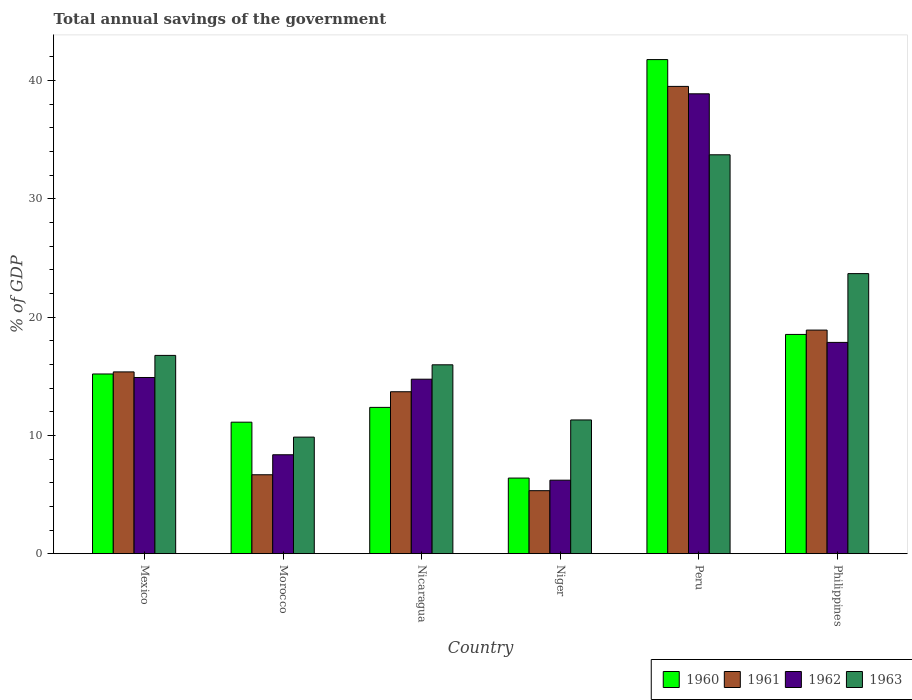How many different coloured bars are there?
Ensure brevity in your answer.  4. Are the number of bars per tick equal to the number of legend labels?
Your response must be concise. Yes. Are the number of bars on each tick of the X-axis equal?
Provide a short and direct response. Yes. How many bars are there on the 2nd tick from the right?
Make the answer very short. 4. What is the label of the 5th group of bars from the left?
Your answer should be compact. Peru. What is the total annual savings of the government in 1961 in Peru?
Keep it short and to the point. 39.51. Across all countries, what is the maximum total annual savings of the government in 1961?
Your answer should be compact. 39.51. Across all countries, what is the minimum total annual savings of the government in 1960?
Offer a terse response. 6.39. In which country was the total annual savings of the government in 1960 minimum?
Ensure brevity in your answer.  Niger. What is the total total annual savings of the government in 1963 in the graph?
Keep it short and to the point. 111.29. What is the difference between the total annual savings of the government in 1960 in Mexico and that in Nicaragua?
Keep it short and to the point. 2.82. What is the difference between the total annual savings of the government in 1961 in Niger and the total annual savings of the government in 1962 in Peru?
Your answer should be compact. -33.56. What is the average total annual savings of the government in 1960 per country?
Give a very brief answer. 17.56. What is the difference between the total annual savings of the government of/in 1962 and total annual savings of the government of/in 1961 in Mexico?
Keep it short and to the point. -0.47. What is the ratio of the total annual savings of the government in 1963 in Morocco to that in Nicaragua?
Give a very brief answer. 0.62. What is the difference between the highest and the second highest total annual savings of the government in 1960?
Your answer should be compact. 23.24. What is the difference between the highest and the lowest total annual savings of the government in 1960?
Give a very brief answer. 35.38. Is the sum of the total annual savings of the government in 1962 in Morocco and Nicaragua greater than the maximum total annual savings of the government in 1963 across all countries?
Offer a terse response. No. Is it the case that in every country, the sum of the total annual savings of the government in 1963 and total annual savings of the government in 1962 is greater than the sum of total annual savings of the government in 1960 and total annual savings of the government in 1961?
Give a very brief answer. No. Is it the case that in every country, the sum of the total annual savings of the government in 1961 and total annual savings of the government in 1963 is greater than the total annual savings of the government in 1962?
Your answer should be compact. Yes. Are all the bars in the graph horizontal?
Offer a terse response. No. What is the difference between two consecutive major ticks on the Y-axis?
Your response must be concise. 10. Are the values on the major ticks of Y-axis written in scientific E-notation?
Give a very brief answer. No. Does the graph contain grids?
Offer a terse response. No. What is the title of the graph?
Your response must be concise. Total annual savings of the government. Does "2002" appear as one of the legend labels in the graph?
Your answer should be compact. No. What is the label or title of the X-axis?
Ensure brevity in your answer.  Country. What is the label or title of the Y-axis?
Your answer should be very brief. % of GDP. What is the % of GDP in 1960 in Mexico?
Your response must be concise. 15.19. What is the % of GDP of 1961 in Mexico?
Provide a succinct answer. 15.37. What is the % of GDP in 1962 in Mexico?
Ensure brevity in your answer.  14.89. What is the % of GDP of 1963 in Mexico?
Provide a succinct answer. 16.76. What is the % of GDP in 1960 in Morocco?
Provide a succinct answer. 11.12. What is the % of GDP of 1961 in Morocco?
Make the answer very short. 6.67. What is the % of GDP in 1962 in Morocco?
Provide a short and direct response. 8.36. What is the % of GDP of 1963 in Morocco?
Offer a very short reply. 9.85. What is the % of GDP of 1960 in Nicaragua?
Keep it short and to the point. 12.37. What is the % of GDP in 1961 in Nicaragua?
Give a very brief answer. 13.69. What is the % of GDP of 1962 in Nicaragua?
Your answer should be compact. 14.75. What is the % of GDP of 1963 in Nicaragua?
Provide a succinct answer. 15.97. What is the % of GDP in 1960 in Niger?
Your answer should be very brief. 6.39. What is the % of GDP of 1961 in Niger?
Your response must be concise. 5.32. What is the % of GDP of 1962 in Niger?
Make the answer very short. 6.21. What is the % of GDP in 1963 in Niger?
Keep it short and to the point. 11.31. What is the % of GDP of 1960 in Peru?
Your answer should be compact. 41.78. What is the % of GDP in 1961 in Peru?
Ensure brevity in your answer.  39.51. What is the % of GDP of 1962 in Peru?
Give a very brief answer. 38.88. What is the % of GDP in 1963 in Peru?
Provide a succinct answer. 33.73. What is the % of GDP in 1960 in Philippines?
Give a very brief answer. 18.54. What is the % of GDP in 1961 in Philippines?
Offer a terse response. 18.9. What is the % of GDP in 1962 in Philippines?
Make the answer very short. 17.86. What is the % of GDP in 1963 in Philippines?
Provide a short and direct response. 23.68. Across all countries, what is the maximum % of GDP in 1960?
Offer a terse response. 41.78. Across all countries, what is the maximum % of GDP of 1961?
Keep it short and to the point. 39.51. Across all countries, what is the maximum % of GDP in 1962?
Ensure brevity in your answer.  38.88. Across all countries, what is the maximum % of GDP in 1963?
Ensure brevity in your answer.  33.73. Across all countries, what is the minimum % of GDP in 1960?
Ensure brevity in your answer.  6.39. Across all countries, what is the minimum % of GDP of 1961?
Offer a terse response. 5.32. Across all countries, what is the minimum % of GDP of 1962?
Offer a terse response. 6.21. Across all countries, what is the minimum % of GDP in 1963?
Your answer should be very brief. 9.85. What is the total % of GDP of 1960 in the graph?
Your answer should be compact. 105.38. What is the total % of GDP in 1961 in the graph?
Ensure brevity in your answer.  99.46. What is the total % of GDP of 1962 in the graph?
Your answer should be compact. 100.96. What is the total % of GDP in 1963 in the graph?
Your answer should be very brief. 111.3. What is the difference between the % of GDP of 1960 in Mexico and that in Morocco?
Your response must be concise. 4.08. What is the difference between the % of GDP of 1961 in Mexico and that in Morocco?
Provide a succinct answer. 8.7. What is the difference between the % of GDP of 1962 in Mexico and that in Morocco?
Your answer should be very brief. 6.53. What is the difference between the % of GDP in 1963 in Mexico and that in Morocco?
Provide a succinct answer. 6.91. What is the difference between the % of GDP of 1960 in Mexico and that in Nicaragua?
Provide a succinct answer. 2.82. What is the difference between the % of GDP in 1961 in Mexico and that in Nicaragua?
Keep it short and to the point. 1.68. What is the difference between the % of GDP of 1962 in Mexico and that in Nicaragua?
Offer a very short reply. 0.14. What is the difference between the % of GDP in 1963 in Mexico and that in Nicaragua?
Offer a terse response. 0.8. What is the difference between the % of GDP in 1960 in Mexico and that in Niger?
Provide a short and direct response. 8.8. What is the difference between the % of GDP in 1961 in Mexico and that in Niger?
Your answer should be very brief. 10.04. What is the difference between the % of GDP in 1962 in Mexico and that in Niger?
Provide a succinct answer. 8.68. What is the difference between the % of GDP of 1963 in Mexico and that in Niger?
Ensure brevity in your answer.  5.46. What is the difference between the % of GDP of 1960 in Mexico and that in Peru?
Your answer should be very brief. -26.58. What is the difference between the % of GDP in 1961 in Mexico and that in Peru?
Give a very brief answer. -24.14. What is the difference between the % of GDP in 1962 in Mexico and that in Peru?
Give a very brief answer. -23.99. What is the difference between the % of GDP in 1963 in Mexico and that in Peru?
Give a very brief answer. -16.96. What is the difference between the % of GDP in 1960 in Mexico and that in Philippines?
Offer a terse response. -3.34. What is the difference between the % of GDP in 1961 in Mexico and that in Philippines?
Ensure brevity in your answer.  -3.54. What is the difference between the % of GDP of 1962 in Mexico and that in Philippines?
Provide a short and direct response. -2.97. What is the difference between the % of GDP in 1963 in Mexico and that in Philippines?
Your response must be concise. -6.92. What is the difference between the % of GDP of 1960 in Morocco and that in Nicaragua?
Ensure brevity in your answer.  -1.25. What is the difference between the % of GDP in 1961 in Morocco and that in Nicaragua?
Keep it short and to the point. -7.02. What is the difference between the % of GDP of 1962 in Morocco and that in Nicaragua?
Provide a short and direct response. -6.39. What is the difference between the % of GDP of 1963 in Morocco and that in Nicaragua?
Offer a very short reply. -6.11. What is the difference between the % of GDP of 1960 in Morocco and that in Niger?
Your answer should be compact. 4.73. What is the difference between the % of GDP of 1961 in Morocco and that in Niger?
Your answer should be very brief. 1.35. What is the difference between the % of GDP of 1962 in Morocco and that in Niger?
Provide a succinct answer. 2.15. What is the difference between the % of GDP in 1963 in Morocco and that in Niger?
Your answer should be very brief. -1.45. What is the difference between the % of GDP of 1960 in Morocco and that in Peru?
Make the answer very short. -30.66. What is the difference between the % of GDP in 1961 in Morocco and that in Peru?
Offer a terse response. -32.84. What is the difference between the % of GDP of 1962 in Morocco and that in Peru?
Keep it short and to the point. -30.52. What is the difference between the % of GDP of 1963 in Morocco and that in Peru?
Offer a very short reply. -23.87. What is the difference between the % of GDP in 1960 in Morocco and that in Philippines?
Your response must be concise. -7.42. What is the difference between the % of GDP in 1961 in Morocco and that in Philippines?
Make the answer very short. -12.23. What is the difference between the % of GDP of 1963 in Morocco and that in Philippines?
Your response must be concise. -13.82. What is the difference between the % of GDP in 1960 in Nicaragua and that in Niger?
Provide a short and direct response. 5.98. What is the difference between the % of GDP of 1961 in Nicaragua and that in Niger?
Your answer should be compact. 8.37. What is the difference between the % of GDP in 1962 in Nicaragua and that in Niger?
Give a very brief answer. 8.54. What is the difference between the % of GDP in 1963 in Nicaragua and that in Niger?
Ensure brevity in your answer.  4.66. What is the difference between the % of GDP of 1960 in Nicaragua and that in Peru?
Your response must be concise. -29.41. What is the difference between the % of GDP in 1961 in Nicaragua and that in Peru?
Keep it short and to the point. -25.82. What is the difference between the % of GDP of 1962 in Nicaragua and that in Peru?
Offer a terse response. -24.13. What is the difference between the % of GDP in 1963 in Nicaragua and that in Peru?
Your response must be concise. -17.76. What is the difference between the % of GDP of 1960 in Nicaragua and that in Philippines?
Offer a very short reply. -6.17. What is the difference between the % of GDP of 1961 in Nicaragua and that in Philippines?
Provide a succinct answer. -5.21. What is the difference between the % of GDP in 1962 in Nicaragua and that in Philippines?
Ensure brevity in your answer.  -3.11. What is the difference between the % of GDP in 1963 in Nicaragua and that in Philippines?
Keep it short and to the point. -7.71. What is the difference between the % of GDP in 1960 in Niger and that in Peru?
Make the answer very short. -35.38. What is the difference between the % of GDP of 1961 in Niger and that in Peru?
Your response must be concise. -34.18. What is the difference between the % of GDP of 1962 in Niger and that in Peru?
Make the answer very short. -32.67. What is the difference between the % of GDP of 1963 in Niger and that in Peru?
Keep it short and to the point. -22.42. What is the difference between the % of GDP of 1960 in Niger and that in Philippines?
Offer a very short reply. -12.15. What is the difference between the % of GDP in 1961 in Niger and that in Philippines?
Your answer should be very brief. -13.58. What is the difference between the % of GDP in 1962 in Niger and that in Philippines?
Give a very brief answer. -11.65. What is the difference between the % of GDP of 1963 in Niger and that in Philippines?
Your answer should be very brief. -12.37. What is the difference between the % of GDP of 1960 in Peru and that in Philippines?
Provide a short and direct response. 23.24. What is the difference between the % of GDP of 1961 in Peru and that in Philippines?
Offer a terse response. 20.6. What is the difference between the % of GDP of 1962 in Peru and that in Philippines?
Your answer should be compact. 21.02. What is the difference between the % of GDP of 1963 in Peru and that in Philippines?
Your answer should be very brief. 10.05. What is the difference between the % of GDP in 1960 in Mexico and the % of GDP in 1961 in Morocco?
Make the answer very short. 8.52. What is the difference between the % of GDP of 1960 in Mexico and the % of GDP of 1962 in Morocco?
Your answer should be very brief. 6.83. What is the difference between the % of GDP in 1960 in Mexico and the % of GDP in 1963 in Morocco?
Provide a succinct answer. 5.34. What is the difference between the % of GDP in 1961 in Mexico and the % of GDP in 1962 in Morocco?
Your response must be concise. 7.01. What is the difference between the % of GDP of 1961 in Mexico and the % of GDP of 1963 in Morocco?
Your response must be concise. 5.51. What is the difference between the % of GDP in 1962 in Mexico and the % of GDP in 1963 in Morocco?
Provide a short and direct response. 5.04. What is the difference between the % of GDP of 1960 in Mexico and the % of GDP of 1961 in Nicaragua?
Your response must be concise. 1.5. What is the difference between the % of GDP of 1960 in Mexico and the % of GDP of 1962 in Nicaragua?
Provide a succinct answer. 0.44. What is the difference between the % of GDP of 1960 in Mexico and the % of GDP of 1963 in Nicaragua?
Make the answer very short. -0.78. What is the difference between the % of GDP of 1961 in Mexico and the % of GDP of 1962 in Nicaragua?
Make the answer very short. 0.62. What is the difference between the % of GDP in 1961 in Mexico and the % of GDP in 1963 in Nicaragua?
Your answer should be very brief. -0.6. What is the difference between the % of GDP in 1962 in Mexico and the % of GDP in 1963 in Nicaragua?
Provide a succinct answer. -1.07. What is the difference between the % of GDP of 1960 in Mexico and the % of GDP of 1961 in Niger?
Your answer should be very brief. 9.87. What is the difference between the % of GDP of 1960 in Mexico and the % of GDP of 1962 in Niger?
Your answer should be very brief. 8.98. What is the difference between the % of GDP in 1960 in Mexico and the % of GDP in 1963 in Niger?
Offer a terse response. 3.89. What is the difference between the % of GDP of 1961 in Mexico and the % of GDP of 1962 in Niger?
Provide a short and direct response. 9.16. What is the difference between the % of GDP of 1961 in Mexico and the % of GDP of 1963 in Niger?
Ensure brevity in your answer.  4.06. What is the difference between the % of GDP of 1962 in Mexico and the % of GDP of 1963 in Niger?
Your response must be concise. 3.59. What is the difference between the % of GDP of 1960 in Mexico and the % of GDP of 1961 in Peru?
Provide a succinct answer. -24.32. What is the difference between the % of GDP in 1960 in Mexico and the % of GDP in 1962 in Peru?
Offer a terse response. -23.69. What is the difference between the % of GDP of 1960 in Mexico and the % of GDP of 1963 in Peru?
Give a very brief answer. -18.53. What is the difference between the % of GDP in 1961 in Mexico and the % of GDP in 1962 in Peru?
Your answer should be very brief. -23.51. What is the difference between the % of GDP in 1961 in Mexico and the % of GDP in 1963 in Peru?
Offer a terse response. -18.36. What is the difference between the % of GDP of 1962 in Mexico and the % of GDP of 1963 in Peru?
Offer a terse response. -18.83. What is the difference between the % of GDP in 1960 in Mexico and the % of GDP in 1961 in Philippines?
Make the answer very short. -3.71. What is the difference between the % of GDP in 1960 in Mexico and the % of GDP in 1962 in Philippines?
Keep it short and to the point. -2.67. What is the difference between the % of GDP of 1960 in Mexico and the % of GDP of 1963 in Philippines?
Provide a short and direct response. -8.49. What is the difference between the % of GDP of 1961 in Mexico and the % of GDP of 1962 in Philippines?
Offer a very short reply. -2.49. What is the difference between the % of GDP in 1961 in Mexico and the % of GDP in 1963 in Philippines?
Your answer should be very brief. -8.31. What is the difference between the % of GDP of 1962 in Mexico and the % of GDP of 1963 in Philippines?
Keep it short and to the point. -8.78. What is the difference between the % of GDP in 1960 in Morocco and the % of GDP in 1961 in Nicaragua?
Your response must be concise. -2.57. What is the difference between the % of GDP of 1960 in Morocco and the % of GDP of 1962 in Nicaragua?
Offer a very short reply. -3.63. What is the difference between the % of GDP in 1960 in Morocco and the % of GDP in 1963 in Nicaragua?
Offer a very short reply. -4.85. What is the difference between the % of GDP of 1961 in Morocco and the % of GDP of 1962 in Nicaragua?
Your answer should be very brief. -8.08. What is the difference between the % of GDP of 1961 in Morocco and the % of GDP of 1963 in Nicaragua?
Offer a terse response. -9.3. What is the difference between the % of GDP of 1962 in Morocco and the % of GDP of 1963 in Nicaragua?
Provide a succinct answer. -7.61. What is the difference between the % of GDP of 1960 in Morocco and the % of GDP of 1961 in Niger?
Offer a terse response. 5.79. What is the difference between the % of GDP in 1960 in Morocco and the % of GDP in 1962 in Niger?
Provide a succinct answer. 4.9. What is the difference between the % of GDP in 1960 in Morocco and the % of GDP in 1963 in Niger?
Keep it short and to the point. -0.19. What is the difference between the % of GDP of 1961 in Morocco and the % of GDP of 1962 in Niger?
Give a very brief answer. 0.46. What is the difference between the % of GDP of 1961 in Morocco and the % of GDP of 1963 in Niger?
Your response must be concise. -4.63. What is the difference between the % of GDP of 1962 in Morocco and the % of GDP of 1963 in Niger?
Offer a terse response. -2.94. What is the difference between the % of GDP of 1960 in Morocco and the % of GDP of 1961 in Peru?
Your answer should be compact. -28.39. What is the difference between the % of GDP of 1960 in Morocco and the % of GDP of 1962 in Peru?
Provide a succinct answer. -27.76. What is the difference between the % of GDP of 1960 in Morocco and the % of GDP of 1963 in Peru?
Your answer should be very brief. -22.61. What is the difference between the % of GDP of 1961 in Morocco and the % of GDP of 1962 in Peru?
Your response must be concise. -32.21. What is the difference between the % of GDP of 1961 in Morocco and the % of GDP of 1963 in Peru?
Your response must be concise. -27.05. What is the difference between the % of GDP in 1962 in Morocco and the % of GDP in 1963 in Peru?
Keep it short and to the point. -25.36. What is the difference between the % of GDP in 1960 in Morocco and the % of GDP in 1961 in Philippines?
Provide a succinct answer. -7.79. What is the difference between the % of GDP of 1960 in Morocco and the % of GDP of 1962 in Philippines?
Provide a short and direct response. -6.75. What is the difference between the % of GDP in 1960 in Morocco and the % of GDP in 1963 in Philippines?
Your response must be concise. -12.56. What is the difference between the % of GDP of 1961 in Morocco and the % of GDP of 1962 in Philippines?
Make the answer very short. -11.19. What is the difference between the % of GDP in 1961 in Morocco and the % of GDP in 1963 in Philippines?
Give a very brief answer. -17.01. What is the difference between the % of GDP in 1962 in Morocco and the % of GDP in 1963 in Philippines?
Provide a short and direct response. -15.32. What is the difference between the % of GDP in 1960 in Nicaragua and the % of GDP in 1961 in Niger?
Your answer should be very brief. 7.04. What is the difference between the % of GDP of 1960 in Nicaragua and the % of GDP of 1962 in Niger?
Your response must be concise. 6.16. What is the difference between the % of GDP in 1960 in Nicaragua and the % of GDP in 1963 in Niger?
Your answer should be very brief. 1.06. What is the difference between the % of GDP of 1961 in Nicaragua and the % of GDP of 1962 in Niger?
Offer a very short reply. 7.48. What is the difference between the % of GDP in 1961 in Nicaragua and the % of GDP in 1963 in Niger?
Your answer should be compact. 2.38. What is the difference between the % of GDP of 1962 in Nicaragua and the % of GDP of 1963 in Niger?
Provide a short and direct response. 3.45. What is the difference between the % of GDP of 1960 in Nicaragua and the % of GDP of 1961 in Peru?
Keep it short and to the point. -27.14. What is the difference between the % of GDP of 1960 in Nicaragua and the % of GDP of 1962 in Peru?
Give a very brief answer. -26.51. What is the difference between the % of GDP of 1960 in Nicaragua and the % of GDP of 1963 in Peru?
Your response must be concise. -21.36. What is the difference between the % of GDP in 1961 in Nicaragua and the % of GDP in 1962 in Peru?
Keep it short and to the point. -25.19. What is the difference between the % of GDP of 1961 in Nicaragua and the % of GDP of 1963 in Peru?
Keep it short and to the point. -20.04. What is the difference between the % of GDP of 1962 in Nicaragua and the % of GDP of 1963 in Peru?
Your answer should be very brief. -18.97. What is the difference between the % of GDP of 1960 in Nicaragua and the % of GDP of 1961 in Philippines?
Your answer should be compact. -6.54. What is the difference between the % of GDP of 1960 in Nicaragua and the % of GDP of 1962 in Philippines?
Offer a very short reply. -5.49. What is the difference between the % of GDP of 1960 in Nicaragua and the % of GDP of 1963 in Philippines?
Make the answer very short. -11.31. What is the difference between the % of GDP in 1961 in Nicaragua and the % of GDP in 1962 in Philippines?
Your answer should be very brief. -4.17. What is the difference between the % of GDP in 1961 in Nicaragua and the % of GDP in 1963 in Philippines?
Ensure brevity in your answer.  -9.99. What is the difference between the % of GDP of 1962 in Nicaragua and the % of GDP of 1963 in Philippines?
Your response must be concise. -8.93. What is the difference between the % of GDP in 1960 in Niger and the % of GDP in 1961 in Peru?
Your response must be concise. -33.12. What is the difference between the % of GDP of 1960 in Niger and the % of GDP of 1962 in Peru?
Offer a very short reply. -32.49. What is the difference between the % of GDP of 1960 in Niger and the % of GDP of 1963 in Peru?
Give a very brief answer. -27.33. What is the difference between the % of GDP of 1961 in Niger and the % of GDP of 1962 in Peru?
Your response must be concise. -33.56. What is the difference between the % of GDP of 1961 in Niger and the % of GDP of 1963 in Peru?
Ensure brevity in your answer.  -28.4. What is the difference between the % of GDP of 1962 in Niger and the % of GDP of 1963 in Peru?
Offer a very short reply. -27.51. What is the difference between the % of GDP of 1960 in Niger and the % of GDP of 1961 in Philippines?
Offer a very short reply. -12.51. What is the difference between the % of GDP of 1960 in Niger and the % of GDP of 1962 in Philippines?
Offer a very short reply. -11.47. What is the difference between the % of GDP in 1960 in Niger and the % of GDP in 1963 in Philippines?
Your answer should be very brief. -17.29. What is the difference between the % of GDP of 1961 in Niger and the % of GDP of 1962 in Philippines?
Your answer should be compact. -12.54. What is the difference between the % of GDP in 1961 in Niger and the % of GDP in 1963 in Philippines?
Keep it short and to the point. -18.35. What is the difference between the % of GDP in 1962 in Niger and the % of GDP in 1963 in Philippines?
Offer a very short reply. -17.47. What is the difference between the % of GDP in 1960 in Peru and the % of GDP in 1961 in Philippines?
Ensure brevity in your answer.  22.87. What is the difference between the % of GDP in 1960 in Peru and the % of GDP in 1962 in Philippines?
Make the answer very short. 23.91. What is the difference between the % of GDP in 1960 in Peru and the % of GDP in 1963 in Philippines?
Offer a very short reply. 18.1. What is the difference between the % of GDP in 1961 in Peru and the % of GDP in 1962 in Philippines?
Ensure brevity in your answer.  21.65. What is the difference between the % of GDP in 1961 in Peru and the % of GDP in 1963 in Philippines?
Give a very brief answer. 15.83. What is the difference between the % of GDP in 1962 in Peru and the % of GDP in 1963 in Philippines?
Give a very brief answer. 15.2. What is the average % of GDP in 1960 per country?
Offer a terse response. 17.56. What is the average % of GDP of 1961 per country?
Your answer should be compact. 16.58. What is the average % of GDP in 1962 per country?
Provide a short and direct response. 16.83. What is the average % of GDP of 1963 per country?
Your answer should be compact. 18.55. What is the difference between the % of GDP in 1960 and % of GDP in 1961 in Mexico?
Your answer should be very brief. -0.18. What is the difference between the % of GDP in 1960 and % of GDP in 1962 in Mexico?
Ensure brevity in your answer.  0.3. What is the difference between the % of GDP of 1960 and % of GDP of 1963 in Mexico?
Your answer should be very brief. -1.57. What is the difference between the % of GDP in 1961 and % of GDP in 1962 in Mexico?
Your response must be concise. 0.47. What is the difference between the % of GDP of 1961 and % of GDP of 1963 in Mexico?
Make the answer very short. -1.4. What is the difference between the % of GDP of 1962 and % of GDP of 1963 in Mexico?
Offer a very short reply. -1.87. What is the difference between the % of GDP of 1960 and % of GDP of 1961 in Morocco?
Keep it short and to the point. 4.45. What is the difference between the % of GDP in 1960 and % of GDP in 1962 in Morocco?
Offer a very short reply. 2.75. What is the difference between the % of GDP of 1960 and % of GDP of 1963 in Morocco?
Give a very brief answer. 1.26. What is the difference between the % of GDP of 1961 and % of GDP of 1962 in Morocco?
Offer a terse response. -1.69. What is the difference between the % of GDP of 1961 and % of GDP of 1963 in Morocco?
Make the answer very short. -3.18. What is the difference between the % of GDP of 1962 and % of GDP of 1963 in Morocco?
Your answer should be compact. -1.49. What is the difference between the % of GDP in 1960 and % of GDP in 1961 in Nicaragua?
Provide a succinct answer. -1.32. What is the difference between the % of GDP in 1960 and % of GDP in 1962 in Nicaragua?
Your answer should be compact. -2.38. What is the difference between the % of GDP of 1960 and % of GDP of 1963 in Nicaragua?
Give a very brief answer. -3.6. What is the difference between the % of GDP in 1961 and % of GDP in 1962 in Nicaragua?
Your answer should be compact. -1.06. What is the difference between the % of GDP in 1961 and % of GDP in 1963 in Nicaragua?
Your answer should be very brief. -2.28. What is the difference between the % of GDP in 1962 and % of GDP in 1963 in Nicaragua?
Your answer should be compact. -1.22. What is the difference between the % of GDP of 1960 and % of GDP of 1961 in Niger?
Keep it short and to the point. 1.07. What is the difference between the % of GDP in 1960 and % of GDP in 1962 in Niger?
Ensure brevity in your answer.  0.18. What is the difference between the % of GDP in 1960 and % of GDP in 1963 in Niger?
Provide a short and direct response. -4.91. What is the difference between the % of GDP of 1961 and % of GDP of 1962 in Niger?
Offer a very short reply. -0.89. What is the difference between the % of GDP of 1961 and % of GDP of 1963 in Niger?
Offer a very short reply. -5.98. What is the difference between the % of GDP of 1962 and % of GDP of 1963 in Niger?
Your answer should be very brief. -5.09. What is the difference between the % of GDP of 1960 and % of GDP of 1961 in Peru?
Give a very brief answer. 2.27. What is the difference between the % of GDP of 1960 and % of GDP of 1962 in Peru?
Offer a terse response. 2.89. What is the difference between the % of GDP of 1960 and % of GDP of 1963 in Peru?
Ensure brevity in your answer.  8.05. What is the difference between the % of GDP of 1961 and % of GDP of 1962 in Peru?
Provide a succinct answer. 0.63. What is the difference between the % of GDP in 1961 and % of GDP in 1963 in Peru?
Make the answer very short. 5.78. What is the difference between the % of GDP in 1962 and % of GDP in 1963 in Peru?
Offer a very short reply. 5.16. What is the difference between the % of GDP of 1960 and % of GDP of 1961 in Philippines?
Keep it short and to the point. -0.37. What is the difference between the % of GDP in 1960 and % of GDP in 1962 in Philippines?
Your answer should be very brief. 0.67. What is the difference between the % of GDP of 1960 and % of GDP of 1963 in Philippines?
Offer a very short reply. -5.14. What is the difference between the % of GDP of 1961 and % of GDP of 1962 in Philippines?
Make the answer very short. 1.04. What is the difference between the % of GDP of 1961 and % of GDP of 1963 in Philippines?
Your answer should be very brief. -4.78. What is the difference between the % of GDP in 1962 and % of GDP in 1963 in Philippines?
Your answer should be compact. -5.82. What is the ratio of the % of GDP in 1960 in Mexico to that in Morocco?
Make the answer very short. 1.37. What is the ratio of the % of GDP in 1961 in Mexico to that in Morocco?
Ensure brevity in your answer.  2.3. What is the ratio of the % of GDP in 1962 in Mexico to that in Morocco?
Provide a succinct answer. 1.78. What is the ratio of the % of GDP of 1963 in Mexico to that in Morocco?
Make the answer very short. 1.7. What is the ratio of the % of GDP of 1960 in Mexico to that in Nicaragua?
Your answer should be very brief. 1.23. What is the ratio of the % of GDP in 1961 in Mexico to that in Nicaragua?
Ensure brevity in your answer.  1.12. What is the ratio of the % of GDP of 1962 in Mexico to that in Nicaragua?
Keep it short and to the point. 1.01. What is the ratio of the % of GDP of 1963 in Mexico to that in Nicaragua?
Keep it short and to the point. 1.05. What is the ratio of the % of GDP in 1960 in Mexico to that in Niger?
Your answer should be very brief. 2.38. What is the ratio of the % of GDP of 1961 in Mexico to that in Niger?
Provide a succinct answer. 2.89. What is the ratio of the % of GDP of 1962 in Mexico to that in Niger?
Your response must be concise. 2.4. What is the ratio of the % of GDP in 1963 in Mexico to that in Niger?
Provide a short and direct response. 1.48. What is the ratio of the % of GDP in 1960 in Mexico to that in Peru?
Give a very brief answer. 0.36. What is the ratio of the % of GDP in 1961 in Mexico to that in Peru?
Ensure brevity in your answer.  0.39. What is the ratio of the % of GDP of 1962 in Mexico to that in Peru?
Make the answer very short. 0.38. What is the ratio of the % of GDP in 1963 in Mexico to that in Peru?
Make the answer very short. 0.5. What is the ratio of the % of GDP of 1960 in Mexico to that in Philippines?
Your response must be concise. 0.82. What is the ratio of the % of GDP of 1961 in Mexico to that in Philippines?
Provide a succinct answer. 0.81. What is the ratio of the % of GDP of 1962 in Mexico to that in Philippines?
Your answer should be very brief. 0.83. What is the ratio of the % of GDP in 1963 in Mexico to that in Philippines?
Keep it short and to the point. 0.71. What is the ratio of the % of GDP in 1960 in Morocco to that in Nicaragua?
Your answer should be very brief. 0.9. What is the ratio of the % of GDP in 1961 in Morocco to that in Nicaragua?
Keep it short and to the point. 0.49. What is the ratio of the % of GDP of 1962 in Morocco to that in Nicaragua?
Ensure brevity in your answer.  0.57. What is the ratio of the % of GDP of 1963 in Morocco to that in Nicaragua?
Your answer should be compact. 0.62. What is the ratio of the % of GDP in 1960 in Morocco to that in Niger?
Ensure brevity in your answer.  1.74. What is the ratio of the % of GDP of 1961 in Morocco to that in Niger?
Offer a terse response. 1.25. What is the ratio of the % of GDP in 1962 in Morocco to that in Niger?
Your answer should be compact. 1.35. What is the ratio of the % of GDP in 1963 in Morocco to that in Niger?
Your answer should be compact. 0.87. What is the ratio of the % of GDP in 1960 in Morocco to that in Peru?
Offer a terse response. 0.27. What is the ratio of the % of GDP in 1961 in Morocco to that in Peru?
Your answer should be very brief. 0.17. What is the ratio of the % of GDP in 1962 in Morocco to that in Peru?
Provide a succinct answer. 0.22. What is the ratio of the % of GDP in 1963 in Morocco to that in Peru?
Your response must be concise. 0.29. What is the ratio of the % of GDP in 1960 in Morocco to that in Philippines?
Provide a short and direct response. 0.6. What is the ratio of the % of GDP in 1961 in Morocco to that in Philippines?
Give a very brief answer. 0.35. What is the ratio of the % of GDP of 1962 in Morocco to that in Philippines?
Make the answer very short. 0.47. What is the ratio of the % of GDP in 1963 in Morocco to that in Philippines?
Make the answer very short. 0.42. What is the ratio of the % of GDP of 1960 in Nicaragua to that in Niger?
Your response must be concise. 1.94. What is the ratio of the % of GDP of 1961 in Nicaragua to that in Niger?
Offer a very short reply. 2.57. What is the ratio of the % of GDP in 1962 in Nicaragua to that in Niger?
Ensure brevity in your answer.  2.37. What is the ratio of the % of GDP of 1963 in Nicaragua to that in Niger?
Give a very brief answer. 1.41. What is the ratio of the % of GDP in 1960 in Nicaragua to that in Peru?
Keep it short and to the point. 0.3. What is the ratio of the % of GDP of 1961 in Nicaragua to that in Peru?
Your answer should be very brief. 0.35. What is the ratio of the % of GDP in 1962 in Nicaragua to that in Peru?
Provide a short and direct response. 0.38. What is the ratio of the % of GDP in 1963 in Nicaragua to that in Peru?
Your answer should be compact. 0.47. What is the ratio of the % of GDP in 1960 in Nicaragua to that in Philippines?
Give a very brief answer. 0.67. What is the ratio of the % of GDP in 1961 in Nicaragua to that in Philippines?
Ensure brevity in your answer.  0.72. What is the ratio of the % of GDP of 1962 in Nicaragua to that in Philippines?
Give a very brief answer. 0.83. What is the ratio of the % of GDP in 1963 in Nicaragua to that in Philippines?
Offer a terse response. 0.67. What is the ratio of the % of GDP in 1960 in Niger to that in Peru?
Your response must be concise. 0.15. What is the ratio of the % of GDP in 1961 in Niger to that in Peru?
Your answer should be compact. 0.13. What is the ratio of the % of GDP in 1962 in Niger to that in Peru?
Offer a very short reply. 0.16. What is the ratio of the % of GDP of 1963 in Niger to that in Peru?
Your answer should be compact. 0.34. What is the ratio of the % of GDP of 1960 in Niger to that in Philippines?
Provide a short and direct response. 0.34. What is the ratio of the % of GDP in 1961 in Niger to that in Philippines?
Make the answer very short. 0.28. What is the ratio of the % of GDP of 1962 in Niger to that in Philippines?
Offer a very short reply. 0.35. What is the ratio of the % of GDP in 1963 in Niger to that in Philippines?
Your answer should be compact. 0.48. What is the ratio of the % of GDP of 1960 in Peru to that in Philippines?
Give a very brief answer. 2.25. What is the ratio of the % of GDP in 1961 in Peru to that in Philippines?
Your answer should be compact. 2.09. What is the ratio of the % of GDP of 1962 in Peru to that in Philippines?
Offer a terse response. 2.18. What is the ratio of the % of GDP of 1963 in Peru to that in Philippines?
Ensure brevity in your answer.  1.42. What is the difference between the highest and the second highest % of GDP in 1960?
Your answer should be very brief. 23.24. What is the difference between the highest and the second highest % of GDP in 1961?
Keep it short and to the point. 20.6. What is the difference between the highest and the second highest % of GDP of 1962?
Provide a short and direct response. 21.02. What is the difference between the highest and the second highest % of GDP of 1963?
Keep it short and to the point. 10.05. What is the difference between the highest and the lowest % of GDP of 1960?
Provide a short and direct response. 35.38. What is the difference between the highest and the lowest % of GDP in 1961?
Give a very brief answer. 34.18. What is the difference between the highest and the lowest % of GDP in 1962?
Your response must be concise. 32.67. What is the difference between the highest and the lowest % of GDP of 1963?
Offer a very short reply. 23.87. 